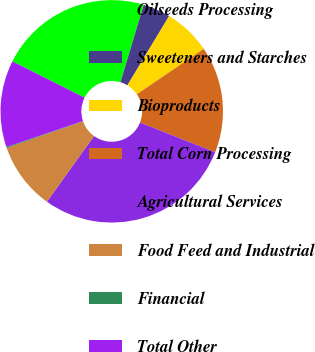<chart> <loc_0><loc_0><loc_500><loc_500><pie_chart><fcel>Oilseeds Processing<fcel>Sweeteners and Starches<fcel>Bioproducts<fcel>Total Corn Processing<fcel>Agricultural Services<fcel>Food Feed and Industrial<fcel>Financial<fcel>Total Other<nl><fcel>22.22%<fcel>3.99%<fcel>6.87%<fcel>15.5%<fcel>28.91%<fcel>9.75%<fcel>0.14%<fcel>12.62%<nl></chart> 